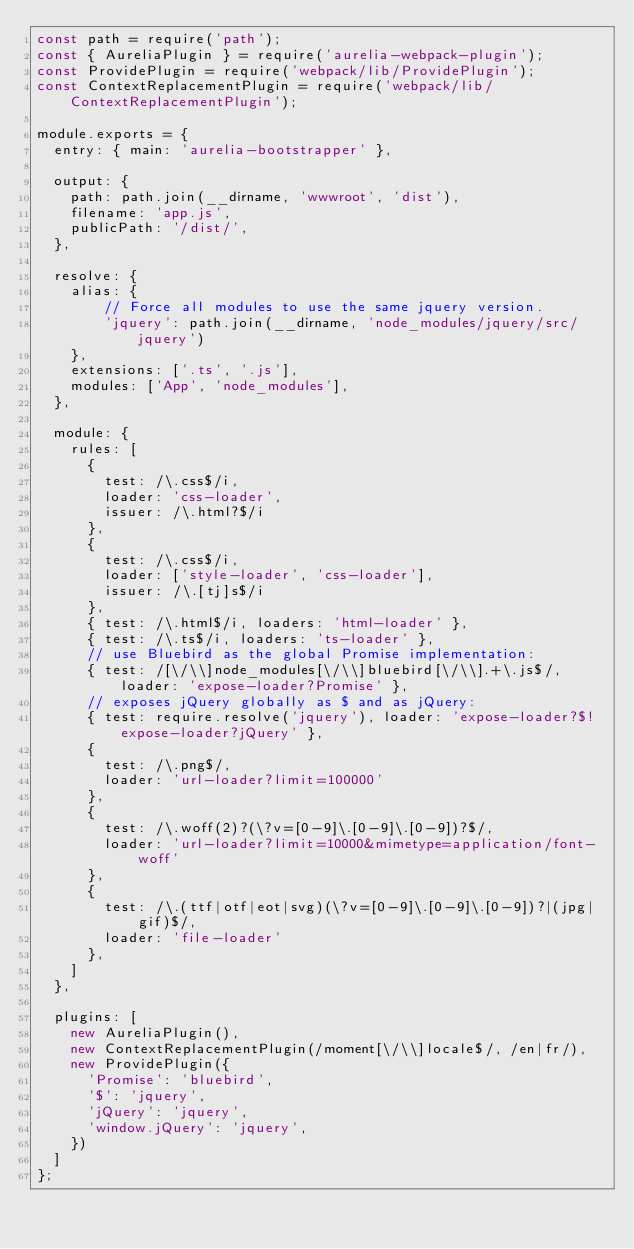<code> <loc_0><loc_0><loc_500><loc_500><_JavaScript_>const path = require('path');
const { AureliaPlugin } = require('aurelia-webpack-plugin');
const ProvidePlugin = require('webpack/lib/ProvidePlugin');
const ContextReplacementPlugin = require('webpack/lib/ContextReplacementPlugin');

module.exports = {
  entry: { main: 'aurelia-bootstrapper' },

  output: {
    path: path.join(__dirname, 'wwwroot', 'dist'),
    filename: 'app.js',
    publicPath: '/dist/',
  },

  resolve: {
    alias: {
        // Force all modules to use the same jquery version.
        'jquery': path.join(__dirname, 'node_modules/jquery/src/jquery')
    },
    extensions: ['.ts', '.js'],
    modules: ['App', 'node_modules'],
  },

  module: {
    rules: [
      {
        test: /\.css$/i,
        loader: 'css-loader',
        issuer: /\.html?$/i
      },
      {
        test: /\.css$/i,
        loader: ['style-loader', 'css-loader'],
        issuer: /\.[tj]s$/i
      },
      { test: /\.html$/i, loaders: 'html-loader' },
      { test: /\.ts$/i, loaders: 'ts-loader' },
      // use Bluebird as the global Promise implementation:
      { test: /[\/\\]node_modules[\/\\]bluebird[\/\\].+\.js$/, loader: 'expose-loader?Promise' },
      // exposes jQuery globally as $ and as jQuery:
      { test: require.resolve('jquery'), loader: 'expose-loader?$!expose-loader?jQuery' },
      {
        test: /\.png$/,
        loader: 'url-loader?limit=100000'
      },
      {
        test: /\.woff(2)?(\?v=[0-9]\.[0-9]\.[0-9])?$/,
        loader: 'url-loader?limit=10000&mimetype=application/font-woff'
      },
      {
        test: /\.(ttf|otf|eot|svg)(\?v=[0-9]\.[0-9]\.[0-9])?|(jpg|gif)$/,
        loader: 'file-loader'
      },
    ]
  },

  plugins: [
    new AureliaPlugin(),
    new ContextReplacementPlugin(/moment[\/\\]locale$/, /en|fr/),
    new ProvidePlugin({
      'Promise': 'bluebird',
      '$': 'jquery',
      'jQuery': 'jquery',
      'window.jQuery': 'jquery',
    })
  ]
};
</code> 